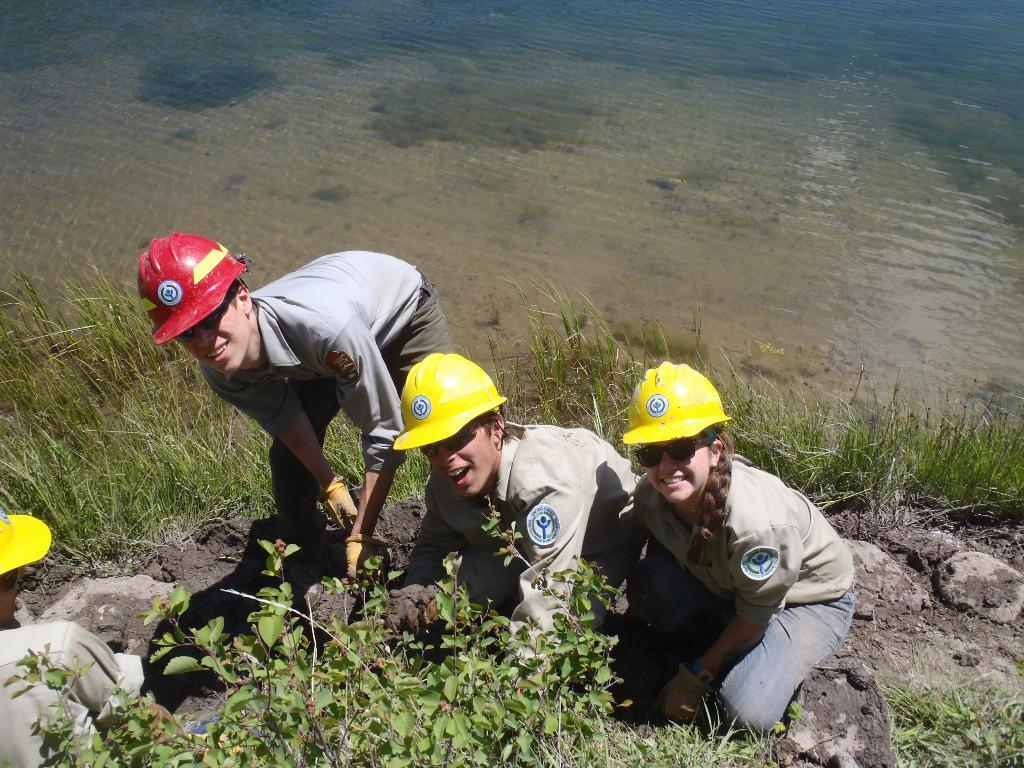How many people are in the image? There are four persons in the image. What is visible in the front of the image? Grass is visible in the front of the image. What protective gear are the persons wearing? All four persons are wearing helmets, shades, and gloves. What can be seen in the background of the image? There is water visible in the background of the image. What type of treatment is the judge receiving in the image? There is no judge or treatment present in the image. What liquid is being poured into the glasses in the image? There is no liquid or glasses present in the image. 